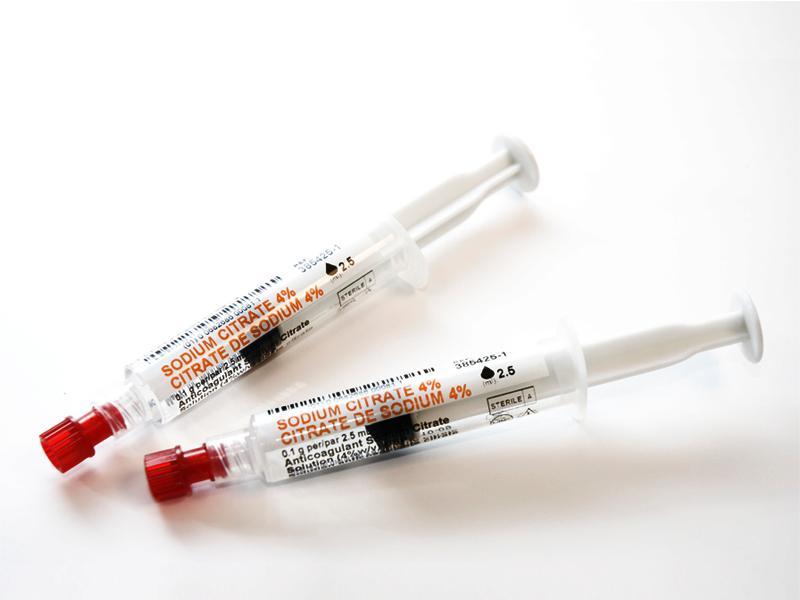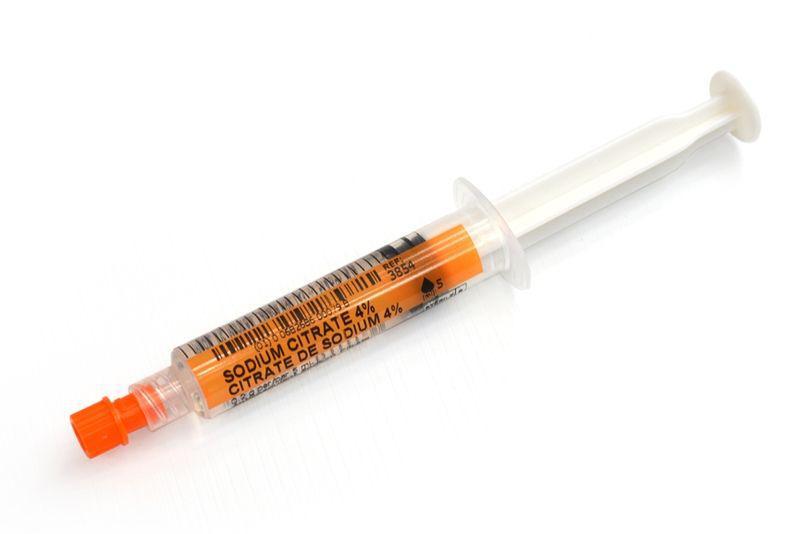The first image is the image on the left, the second image is the image on the right. Examine the images to the left and right. Is the description "there is at least one syringe in the image on the left" accurate? Answer yes or no. Yes. The first image is the image on the left, the second image is the image on the right. Considering the images on both sides, is "One of the syringes has a grey plunger." valid? Answer yes or no. No. 